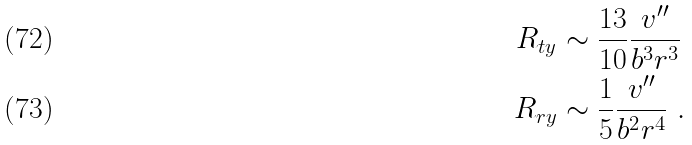Convert formula to latex. <formula><loc_0><loc_0><loc_500><loc_500>R _ { t y } & \sim \frac { 1 3 } { 1 0 } \frac { v ^ { \prime \prime } } { b ^ { 3 } r ^ { 3 } } \ \\ R _ { r y } & \sim \frac { 1 } { 5 } \frac { v ^ { \prime \prime } } { b ^ { 2 } r ^ { 4 } } \ .</formula> 